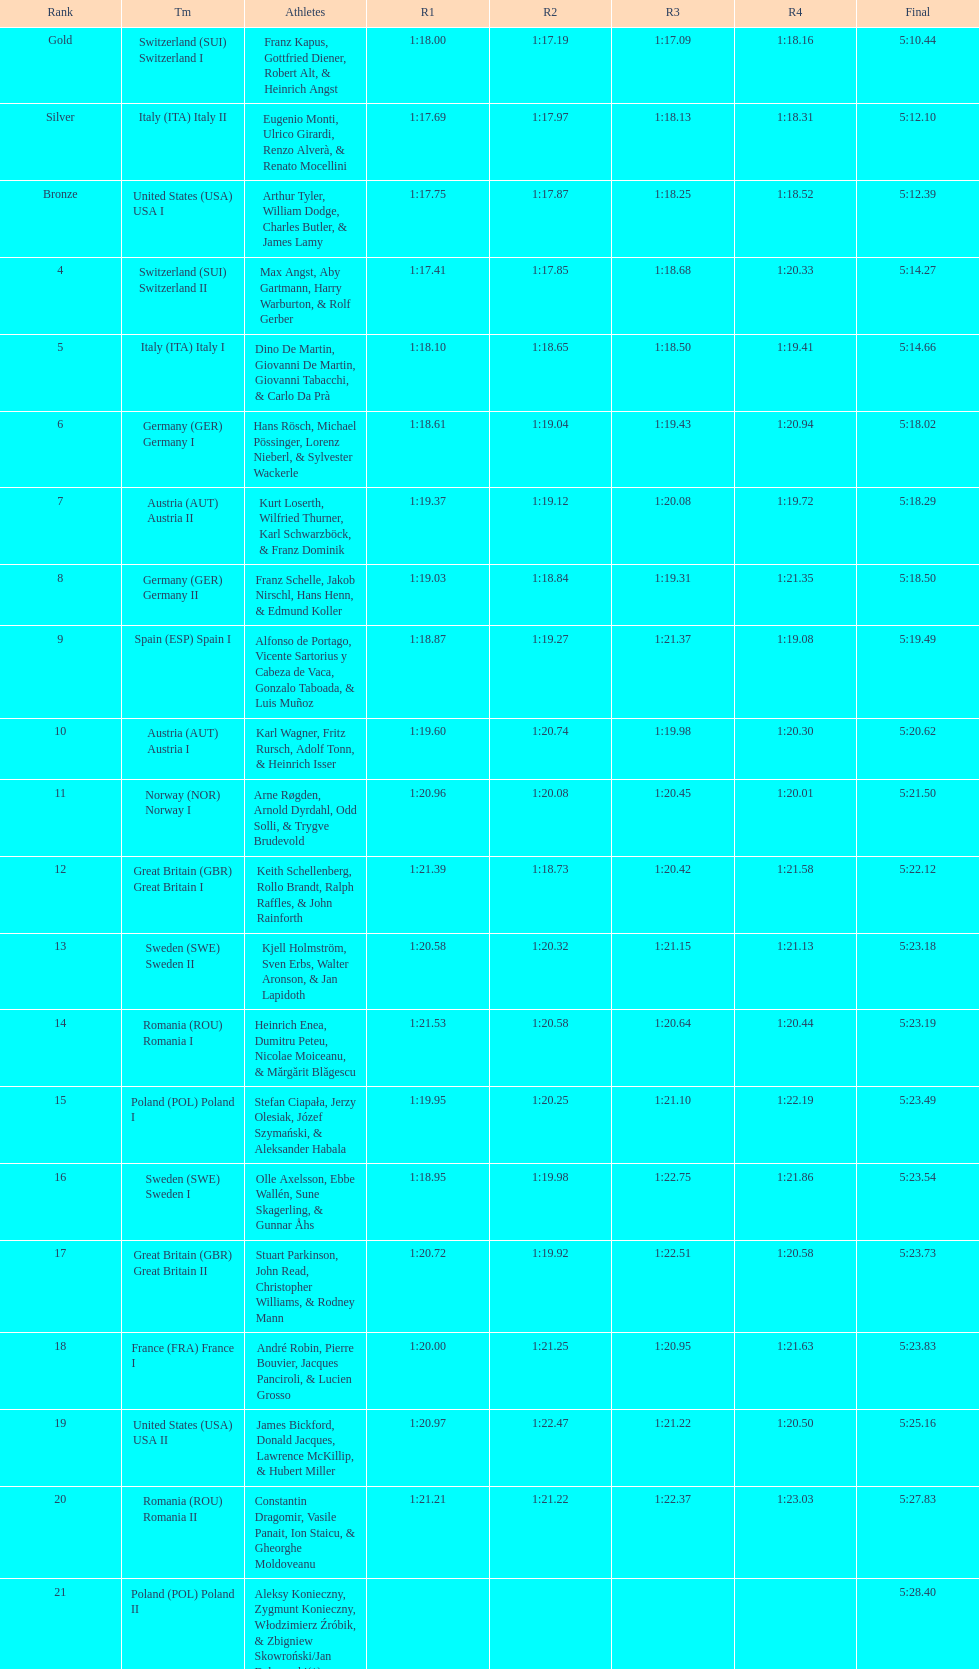What group succeeds italy (ita) italy i? Germany I. 